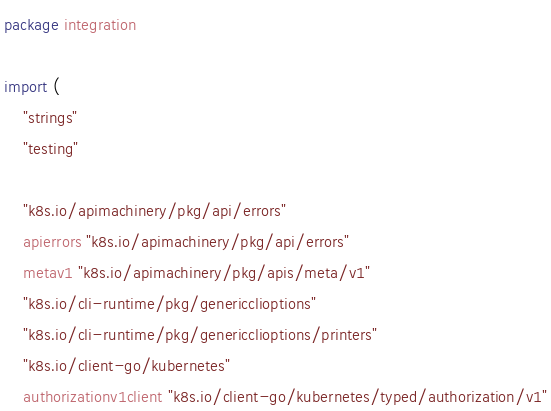Convert code to text. <code><loc_0><loc_0><loc_500><loc_500><_Go_>package integration

import (
	"strings"
	"testing"

	"k8s.io/apimachinery/pkg/api/errors"
	apierrors "k8s.io/apimachinery/pkg/api/errors"
	metav1 "k8s.io/apimachinery/pkg/apis/meta/v1"
	"k8s.io/cli-runtime/pkg/genericclioptions"
	"k8s.io/cli-runtime/pkg/genericclioptions/printers"
	"k8s.io/client-go/kubernetes"
	authorizationv1client "k8s.io/client-go/kubernetes/typed/authorization/v1"</code> 